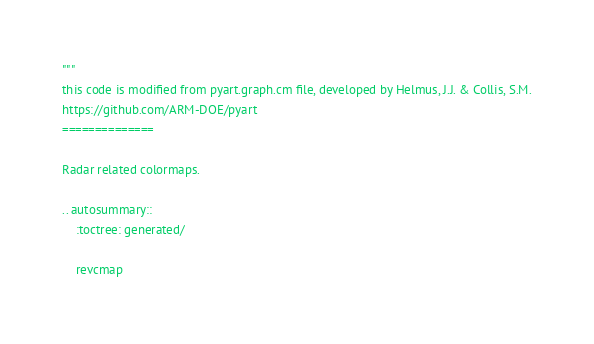Convert code to text. <code><loc_0><loc_0><loc_500><loc_500><_Python_>"""
this code is modified from pyart.graph.cm file, developed by Helmus, J.J. & Collis, S.M.
https://github.com/ARM-DOE/pyart
==============

Radar related colormaps.

.. autosummary::
    :toctree: generated/

    revcmap</code> 